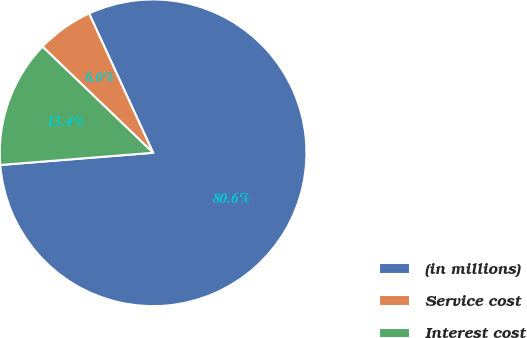<chart> <loc_0><loc_0><loc_500><loc_500><pie_chart><fcel>(in millions)<fcel>Service cost<fcel>Interest cost<nl><fcel>80.59%<fcel>5.97%<fcel>13.44%<nl></chart> 